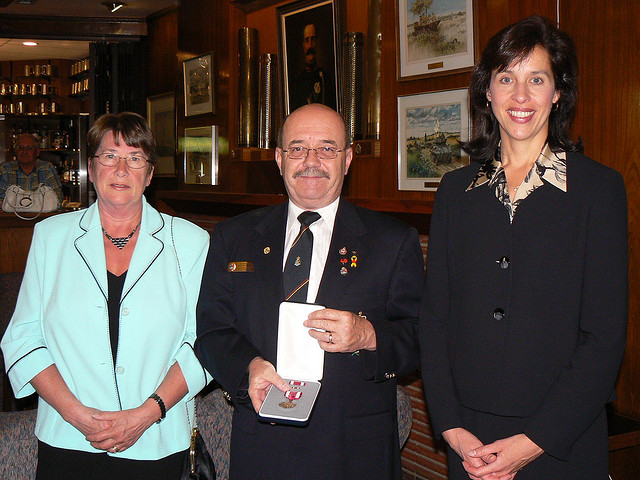How many people are in the photo? There are three individuals visible in the photograph, all of whom are posing formally. 